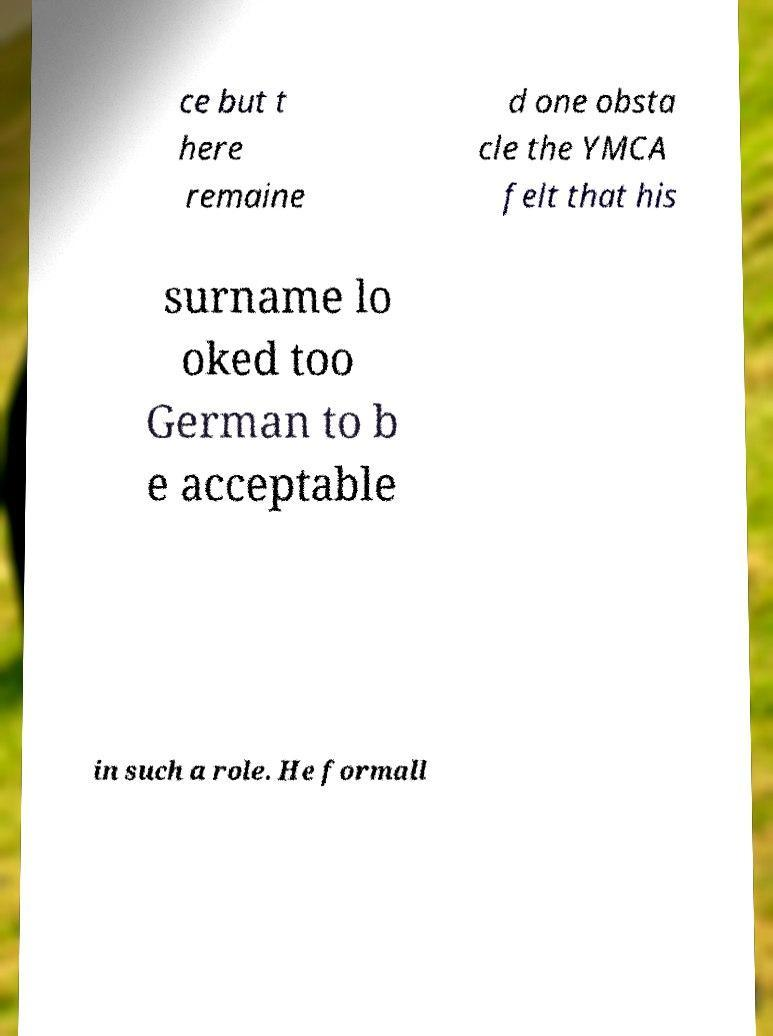Please identify and transcribe the text found in this image. ce but t here remaine d one obsta cle the YMCA felt that his surname lo oked too German to b e acceptable in such a role. He formall 